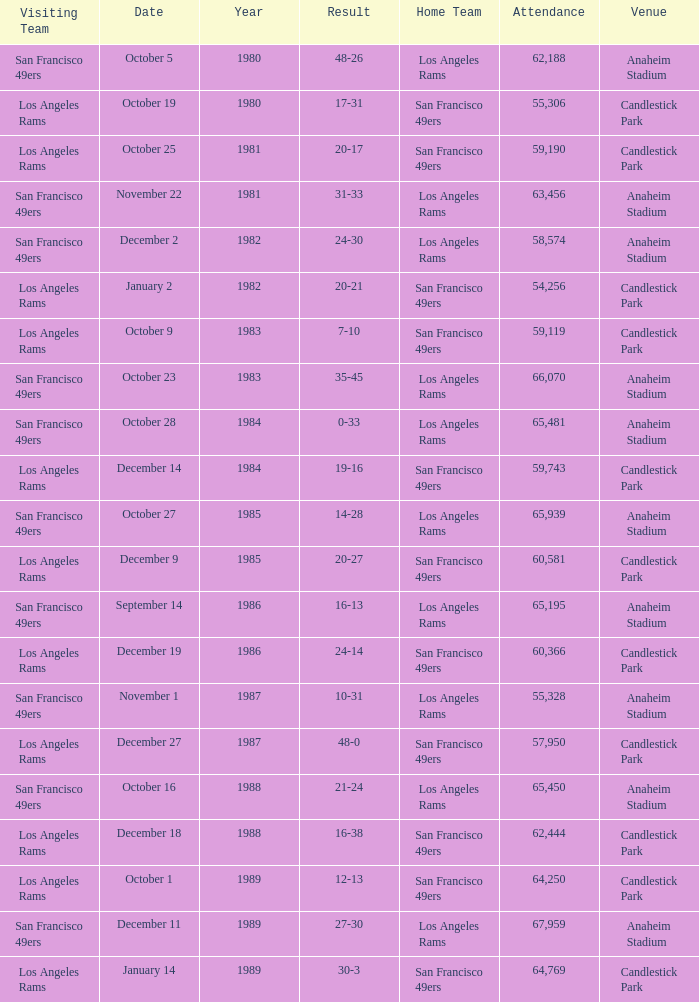What's the total attendance at anaheim stadium after 1983 when the result is 14-28? 1.0. 